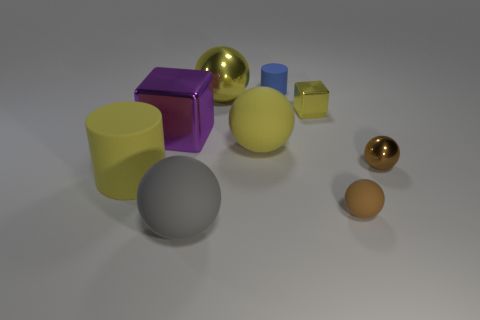Subtract 1 spheres. How many spheres are left? 4 Subtract all purple balls. Subtract all cyan cylinders. How many balls are left? 5 Subtract all spheres. How many objects are left? 4 Subtract all cyan rubber balls. Subtract all tiny metallic cubes. How many objects are left? 8 Add 4 small brown objects. How many small brown objects are left? 6 Add 3 large gray things. How many large gray things exist? 4 Subtract 1 yellow cylinders. How many objects are left? 8 